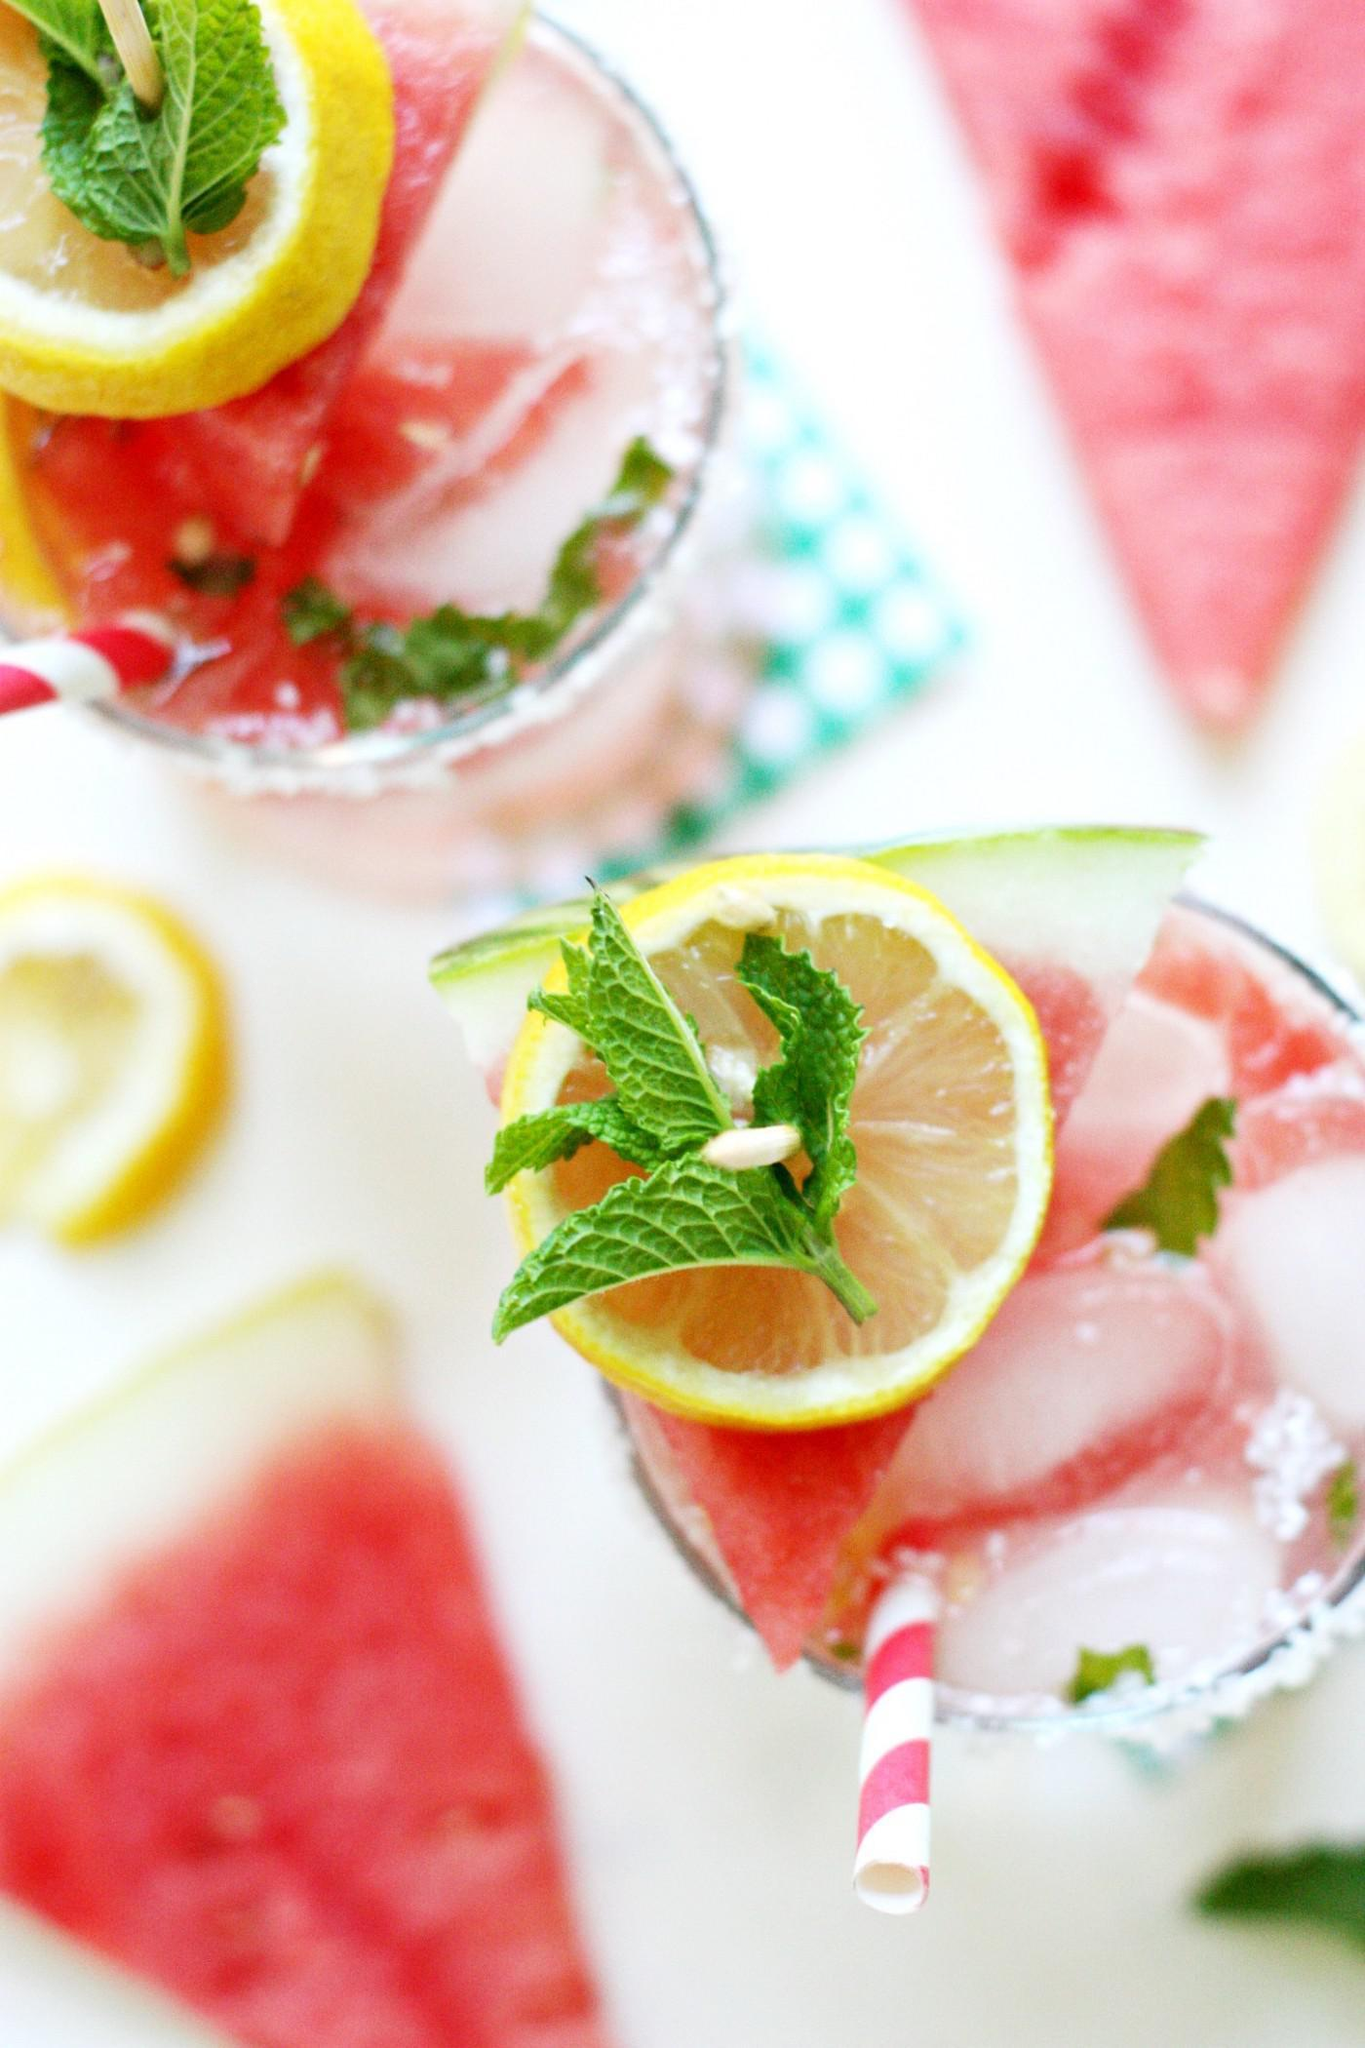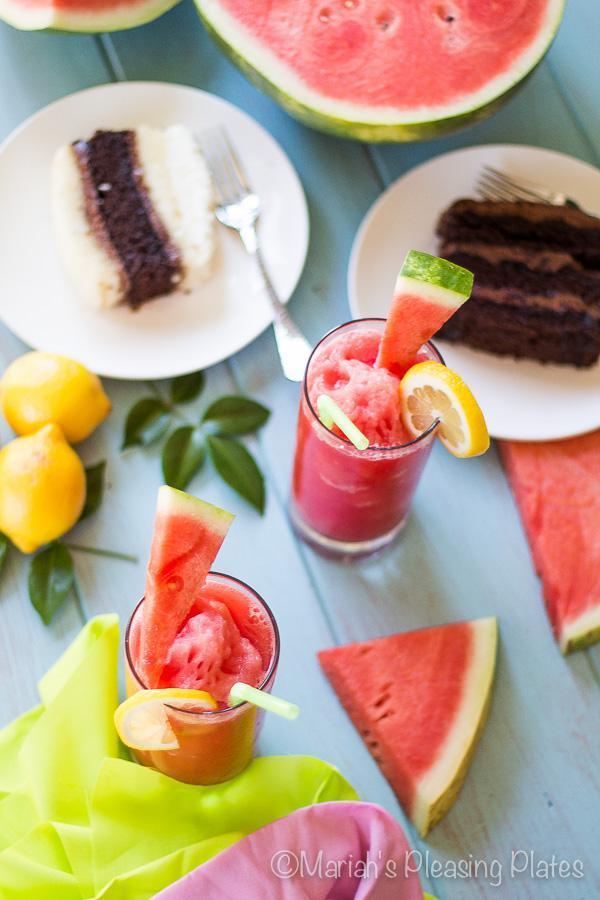The first image is the image on the left, the second image is the image on the right. Assess this claim about the two images: "Each of the images features fresh watermelon slices along with popsicles.". Correct or not? Answer yes or no. No. The first image is the image on the left, the second image is the image on the right. For the images shown, is this caption "An image shows a whole lemon along with watermelon imagery." true? Answer yes or no. Yes. 